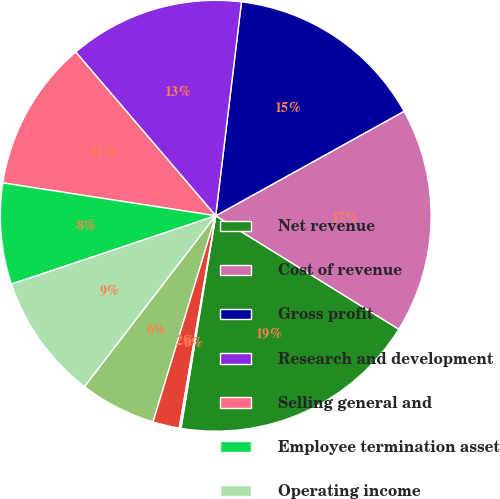Convert chart to OTSL. <chart><loc_0><loc_0><loc_500><loc_500><pie_chart><fcel>Net revenue<fcel>Cost of revenue<fcel>Gross profit<fcel>Research and development<fcel>Selling general and<fcel>Employee termination asset<fcel>Operating income<fcel>Other expense net<fcel>Income before income taxes<fcel>Income tax expense (benefit)<nl><fcel>18.75%<fcel>16.89%<fcel>15.03%<fcel>13.17%<fcel>11.3%<fcel>7.58%<fcel>9.44%<fcel>5.72%<fcel>1.99%<fcel>0.13%<nl></chart> 